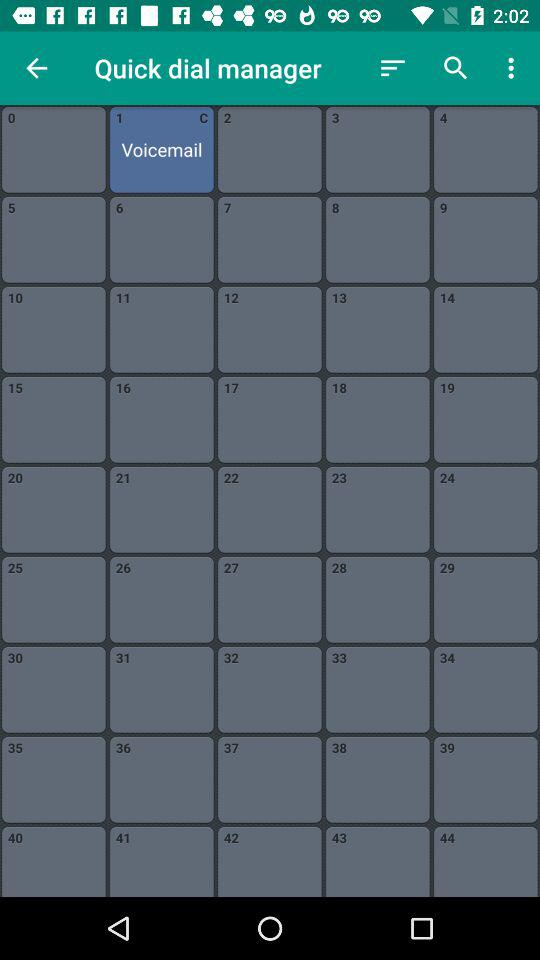On the Quick dial manager, what does 1 indicate? The number 1 indicates "Voicemail". 